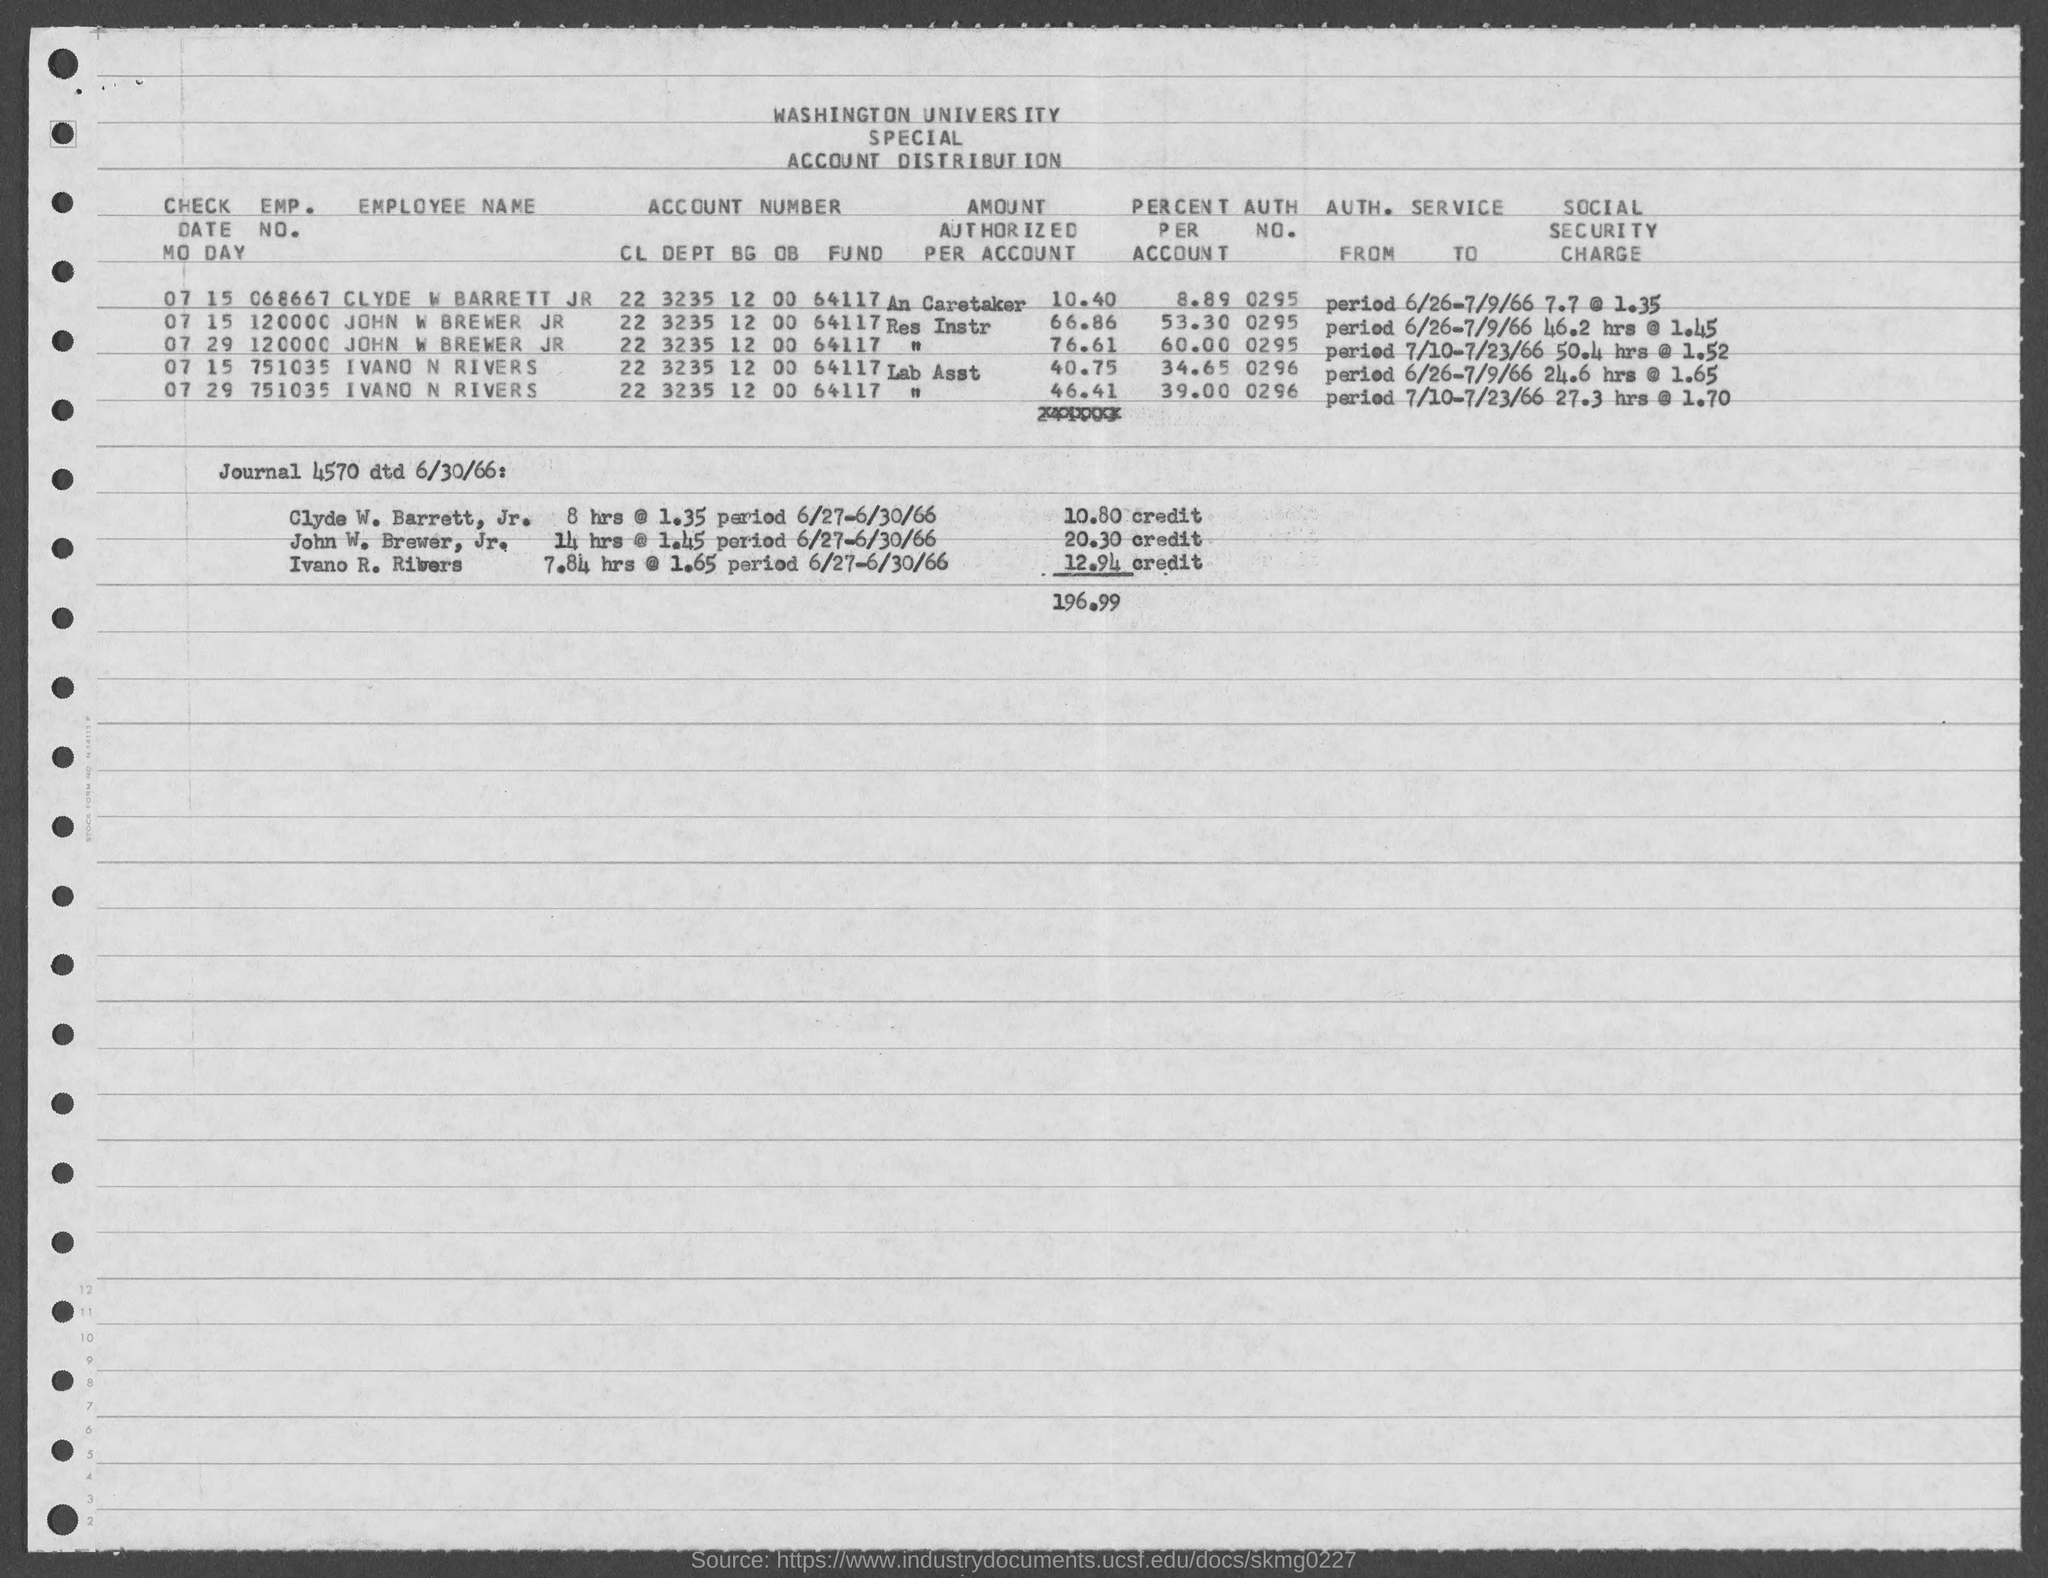Point out several critical features in this image. Clyde W. Barrett Jr.'s employment number is 068667. I'm sorry, but the given text appears to be a combination of numbers and letters that does not form a complete sentence. Can you please provide more context or clarify what you are asking? The emp. no. of Ivano N Rivers mentioned in the given page is 751035. The emp. no. of John W Brewer jr, as mentioned on the given page, is 120000. The authorization number for Ivan N Rivers is 0296... 